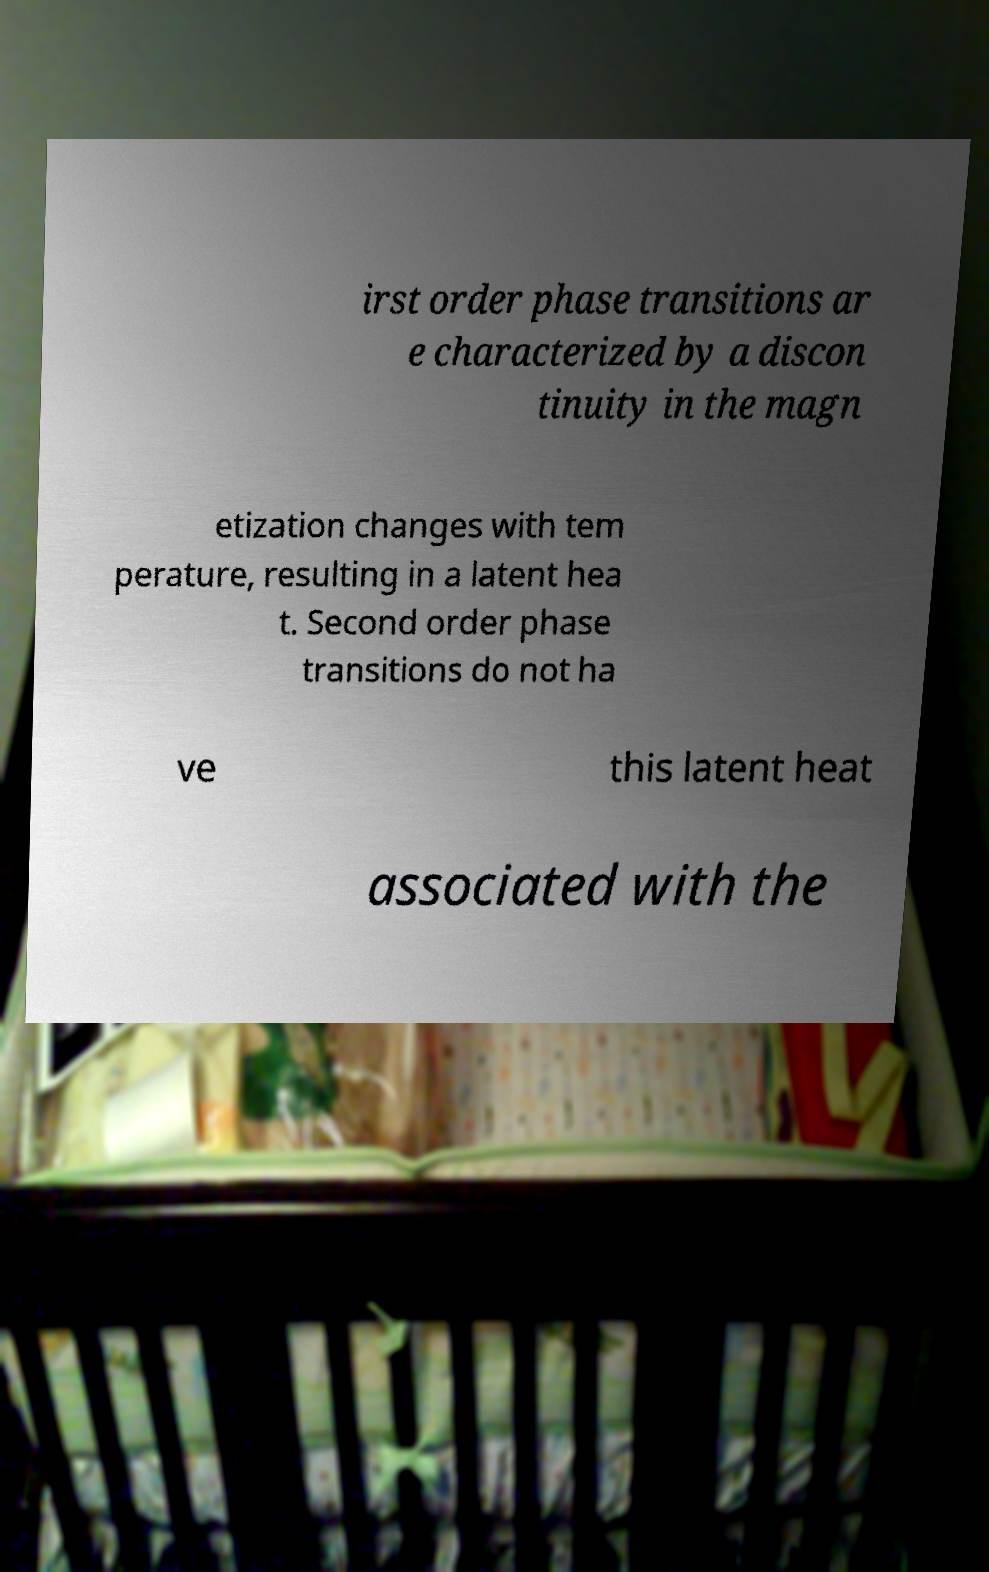Can you accurately transcribe the text from the provided image for me? irst order phase transitions ar e characterized by a discon tinuity in the magn etization changes with tem perature, resulting in a latent hea t. Second order phase transitions do not ha ve this latent heat associated with the 